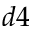Convert formula to latex. <formula><loc_0><loc_0><loc_500><loc_500>d 4</formula> 